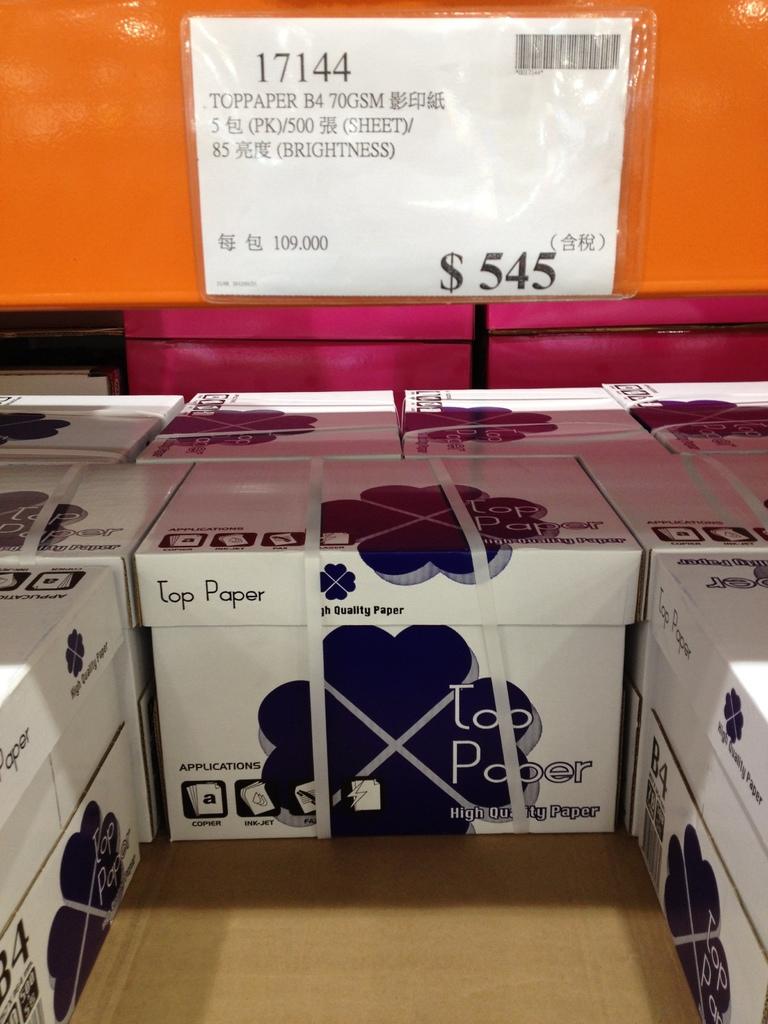What brand is this paper?
Your answer should be compact. Top paper. How much does it cost?
Ensure brevity in your answer.  $545. 